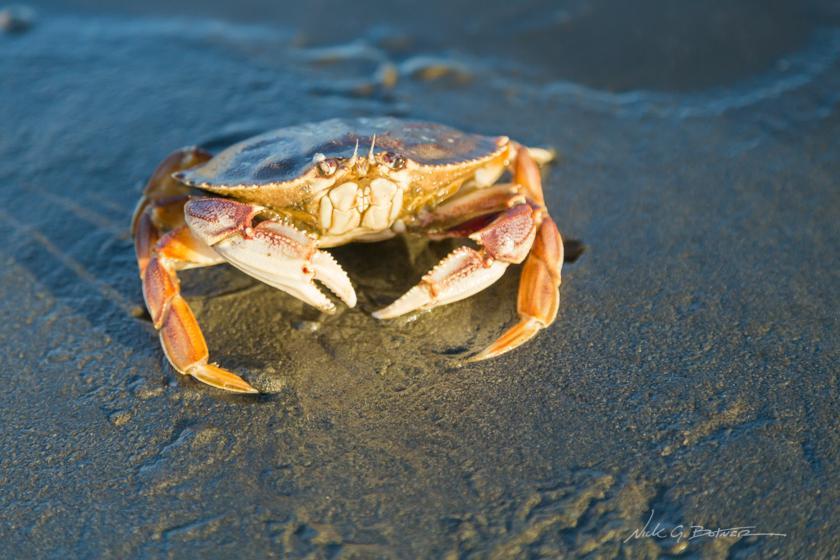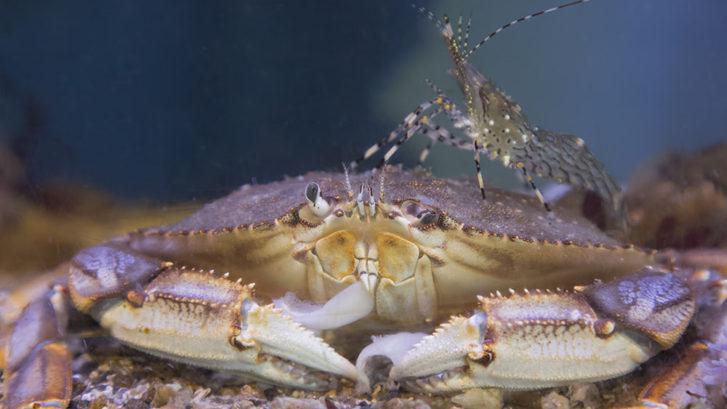The first image is the image on the left, the second image is the image on the right. Examine the images to the left and right. Is the description "An image shows one bare hand with the thumb on the right holding up a belly-first, head-up crab, with water in the background." accurate? Answer yes or no. No. The first image is the image on the left, the second image is the image on the right. Analyze the images presented: Is the assertion "A crab is being held vertically." valid? Answer yes or no. No. 